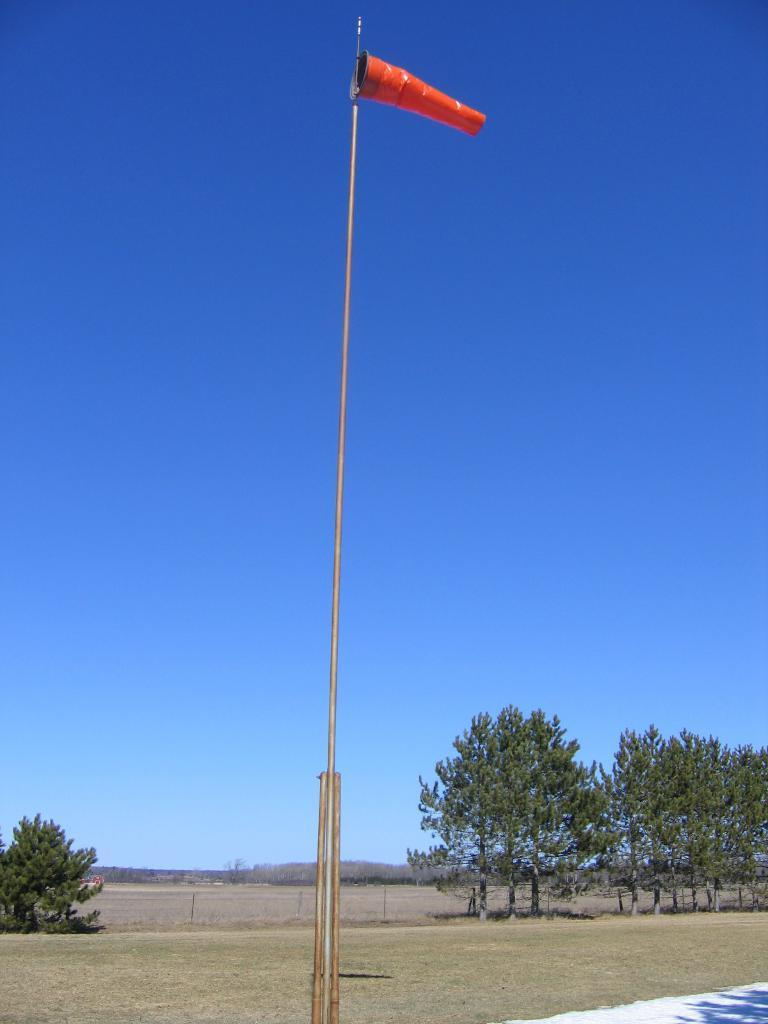What type of vegetation can be seen in the image? There are trees in the image. What is visible at the top of the image? The sky is visible at the top of the image. What structure can be seen in the image? There is a pole in the image. What type of barrier is present in the image? There is a fence in the image. What type of drink is being served in a vase in the image? There is no vase or drink present in the image. What type of material is the lead fence made of in the image? There is no lead material or fence present in the image. 